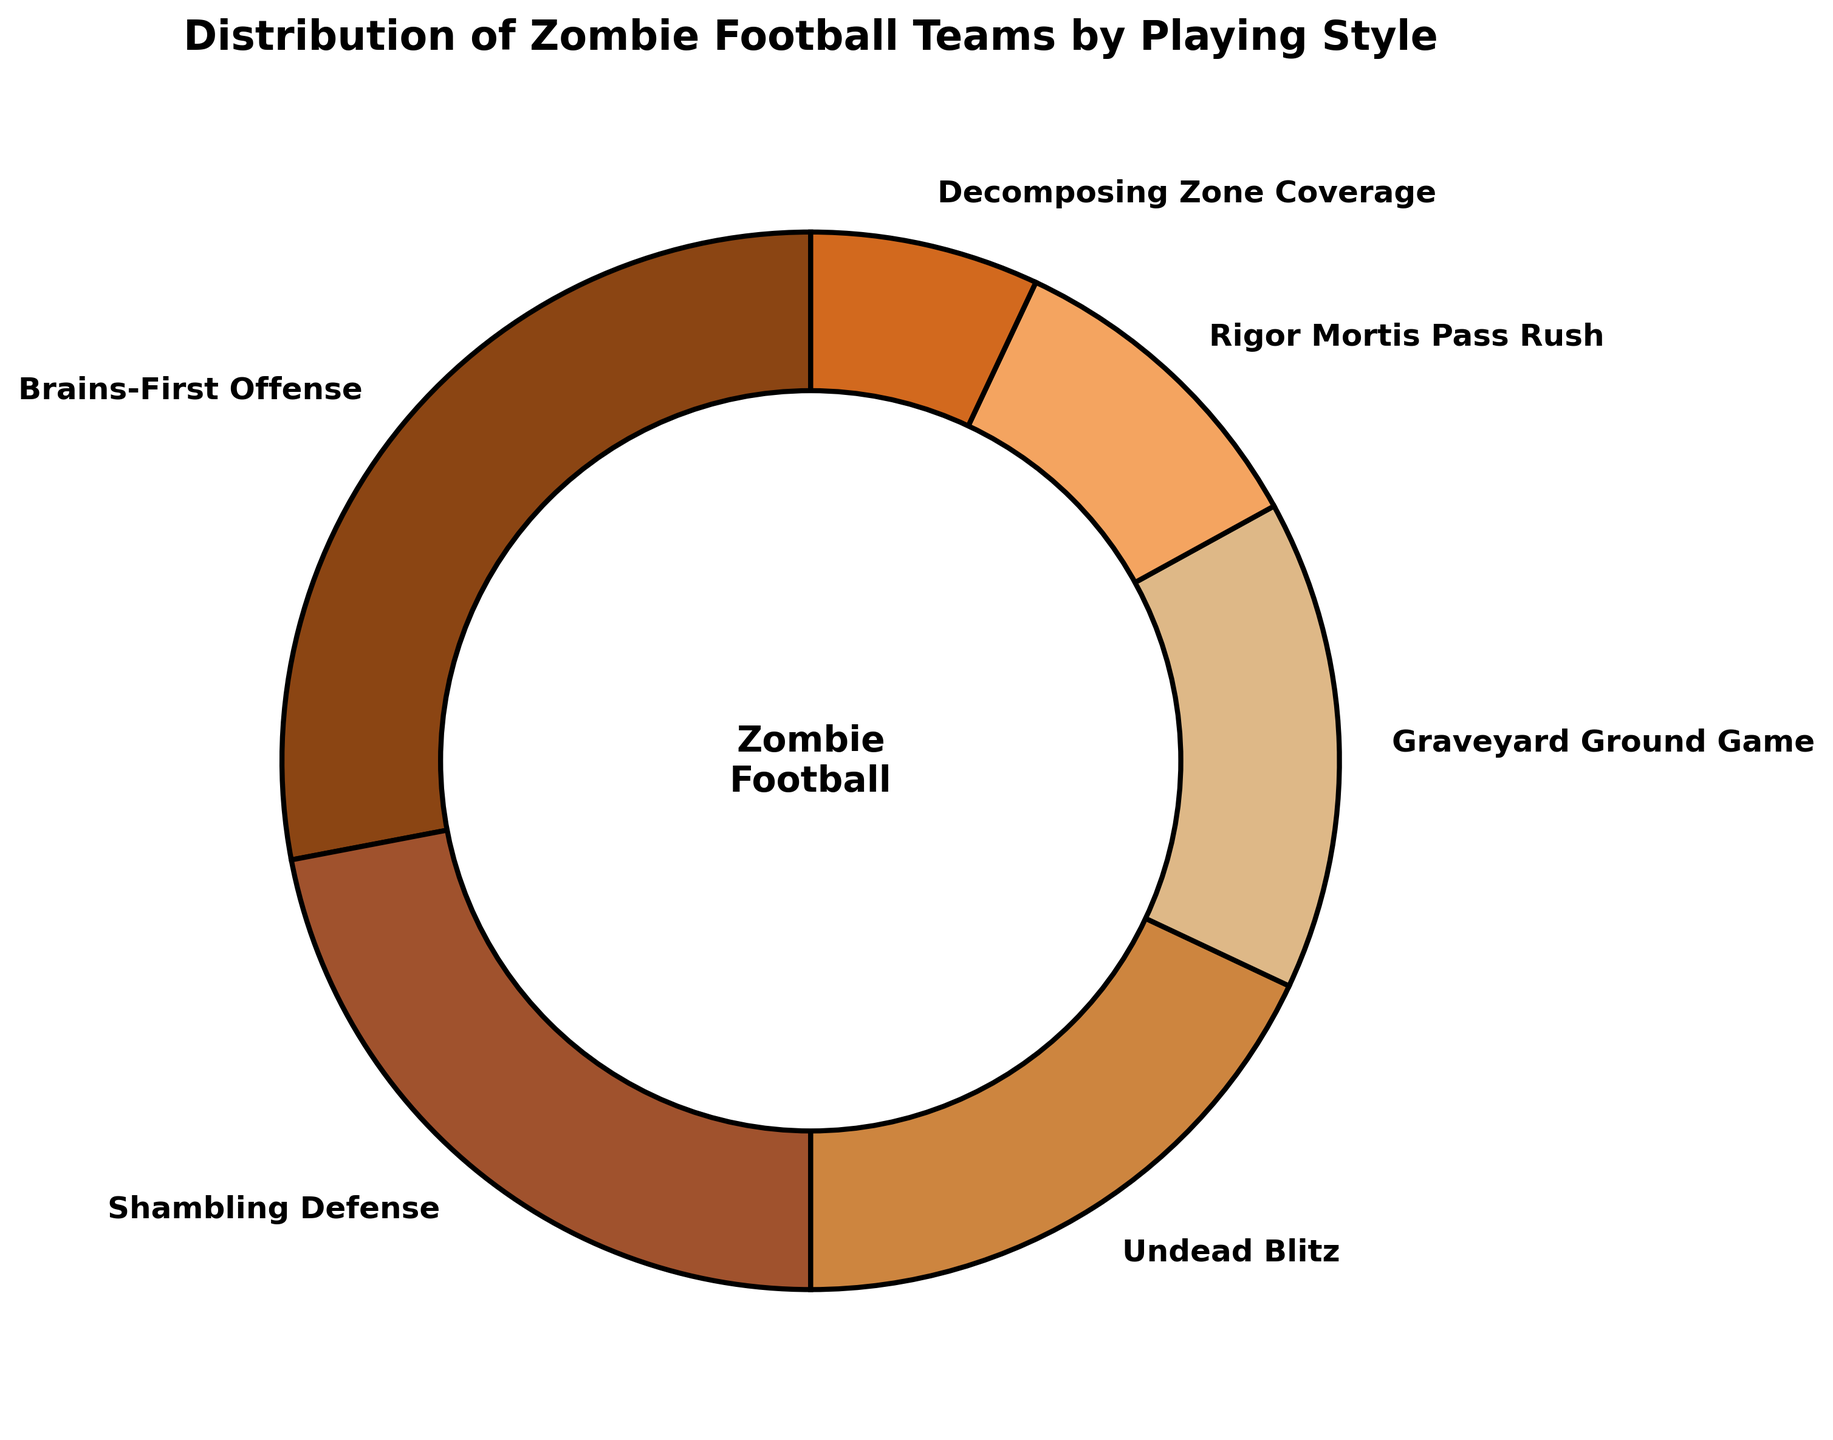What is the most common playing style among zombie football teams? The segment representing "Brains-First Offense" is the largest with 28% of the total. This indicates it is the most common style.
Answer: Brains-First Offense Which playing style has the second smallest percentage? The chart shows "Decomposing Zone Coverage" with the smallest at 7%, and "Rigor Mortis Pass Rush" next with 10%.
Answer: Rigor Mortis Pass Rush What is the percentage difference between the "Brains-First Offense" and "Undead Blitz" styles? "Brains-First Offense" is at 28% while "Undead Blitz" is at 18%. Subtracting these gives a difference: 28% - 18% = 10%.
Answer: 10% What combined percentage of zombie football teams prefer either "Shambling Defense" or "Graveyard Ground Game"? The pie chart shows 22% for "Shambling Defense" and 15% for "Graveyard Ground Game." Adding these: 22% + 15% = 37%.
Answer: 37% How many playing styles have percentages greater than 20%? The segments with "Brains-First Offense" (28%) and "Shambling Defense" (22%) are both greater than 20%. Thus, there are 2 styles.
Answer: 2 Which playing style appears in shades of brown closest to the center? The center circle segment appears surrounded by shades of brown, indicating "Brains-First Offense".
Answer: Brains-First Offense If the percentages of "Decomposing Zone Coverage" and "Rigor Mortis Pass Rush" are combined, how does their total compare to "Graveyard Ground Game"? "Decomposing Zone Coverage" is at 7% and "Rigor Mortis Pass Rush" at 10%, summing to 17%. This is greater than the 15% of "Graveyard Ground Game".
Answer: Greater What’s the average percentage of the three smallest playing styles combined? The three smallest styles are "Rigor Mortis Pass Rush" (10%), "Decomposing Zone Coverage" (7%), and "Graveyard Ground Game" (15%). Summed, they total to 32%. Their average is: 32% / 3 ≈ 10.67%.
Answer: 10.67% Which playing style uses the second darkest shade of brown? "Shambling Defense" is represented by the second darkest shade of brown in the pie chart near the outer ring.
Answer: Shambling Defense 